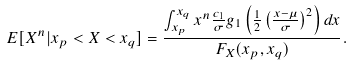<formula> <loc_0><loc_0><loc_500><loc_500>E [ X ^ { n } | x _ { p } < X < x _ { q } ] = \frac { \int _ { x _ { p } } ^ { x _ { q } } x ^ { n } \frac { c _ { 1 } } { \sigma } g _ { 1 } \left ( \frac { 1 } { 2 } \left ( \frac { x - \mu } { \sigma } \right ) ^ { 2 } \right ) d x } { F _ { X } ( x _ { p } , x _ { q } ) } .</formula> 